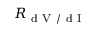Convert formula to latex. <formula><loc_0><loc_0><loc_500><loc_500>R _ { d V / d I }</formula> 